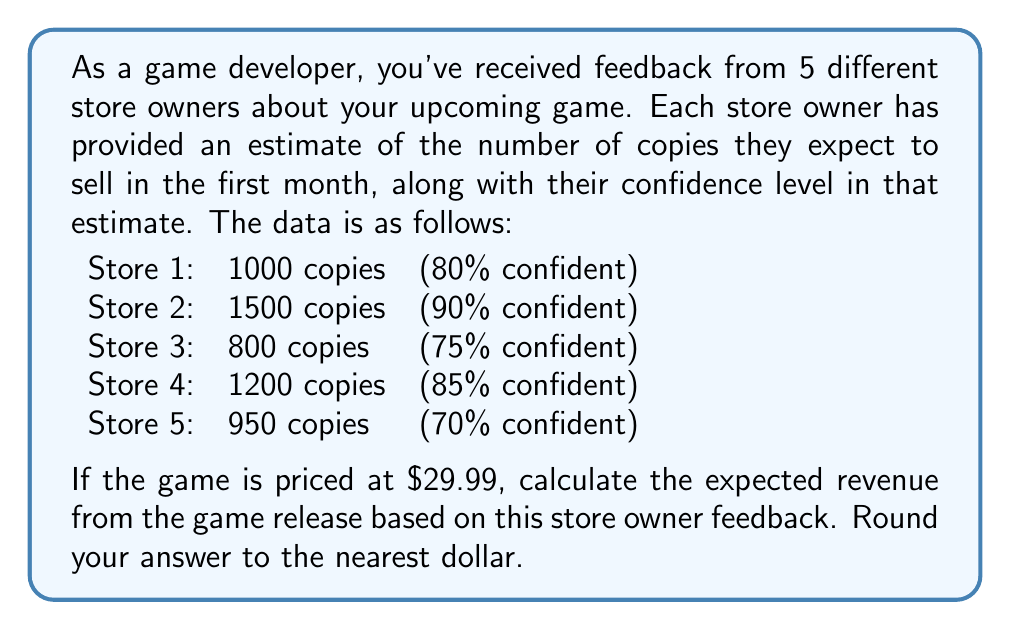Help me with this question. To solve this problem, we'll use the concept of expected value for random variables. We'll treat each store's estimate as a random variable, weighted by their confidence level.

1. First, let's calculate the weighted average of the estimates:

   $$ \text{Weighted Average} = \frac{\sum (\text{Estimate} \times \text{Confidence})}{\sum \text{Confidence}} $$

   $$ = \frac{1000 \times 0.80 + 1500 \times 0.90 + 800 \times 0.75 + 1200 \times 0.85 + 950 \times 0.70}{0.80 + 0.90 + 0.75 + 0.85 + 0.70} $$

   $$ = \frac{800 + 1350 + 600 + 1020 + 665}{4} $$

   $$ = \frac{4435}{4} = 1108.75 \text{ copies} $$

2. Now that we have the expected number of copies to be sold, we can calculate the expected revenue:

   $$ \text{Expected Revenue} = \text{Expected Copies} \times \text{Price per Copy} $$

   $$ = 1108.75 \times \$29.99 $$

   $$ = \$33,251.41 $$

3. Rounding to the nearest dollar:

   $$ \text{Expected Revenue} \approx \$33,251 $$
Answer: $33,251 